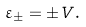<formula> <loc_0><loc_0><loc_500><loc_500>\varepsilon _ { \pm } = \pm V .</formula> 